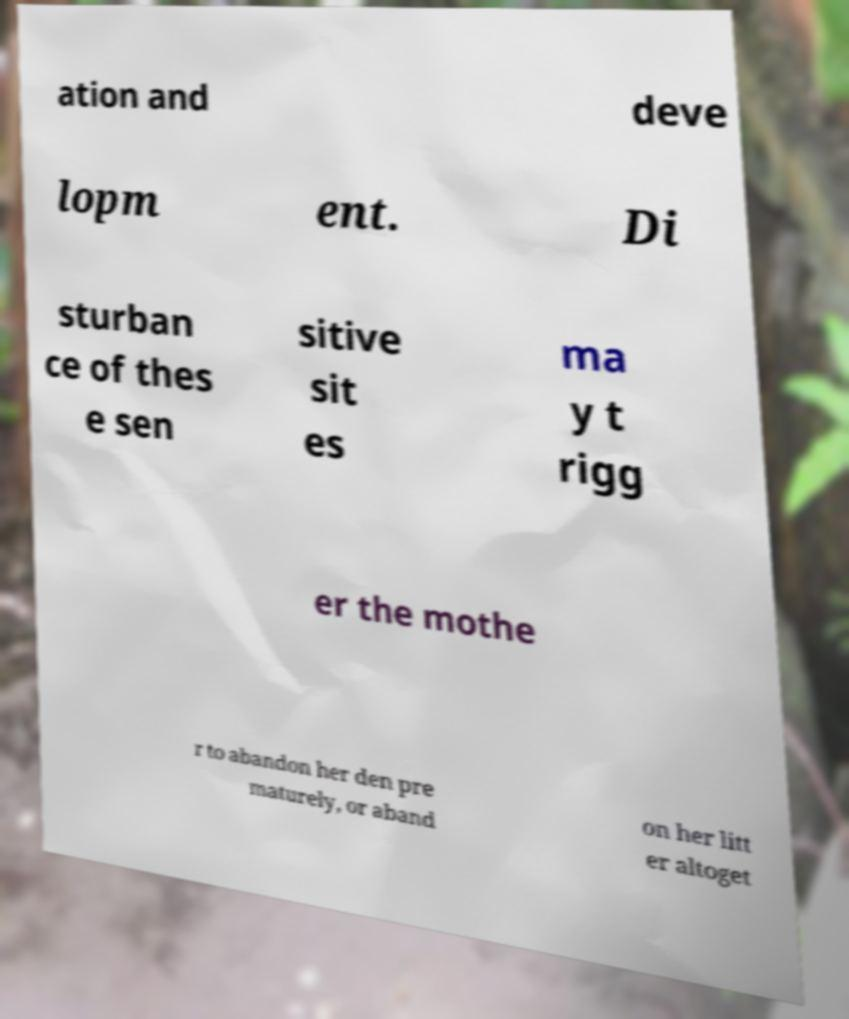Could you extract and type out the text from this image? ation and deve lopm ent. Di sturban ce of thes e sen sitive sit es ma y t rigg er the mothe r to abandon her den pre maturely, or aband on her litt er altoget 